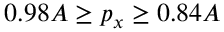<formula> <loc_0><loc_0><loc_500><loc_500>0 . 9 8 A \geq p _ { x } \geq 0 . 8 4 A</formula> 